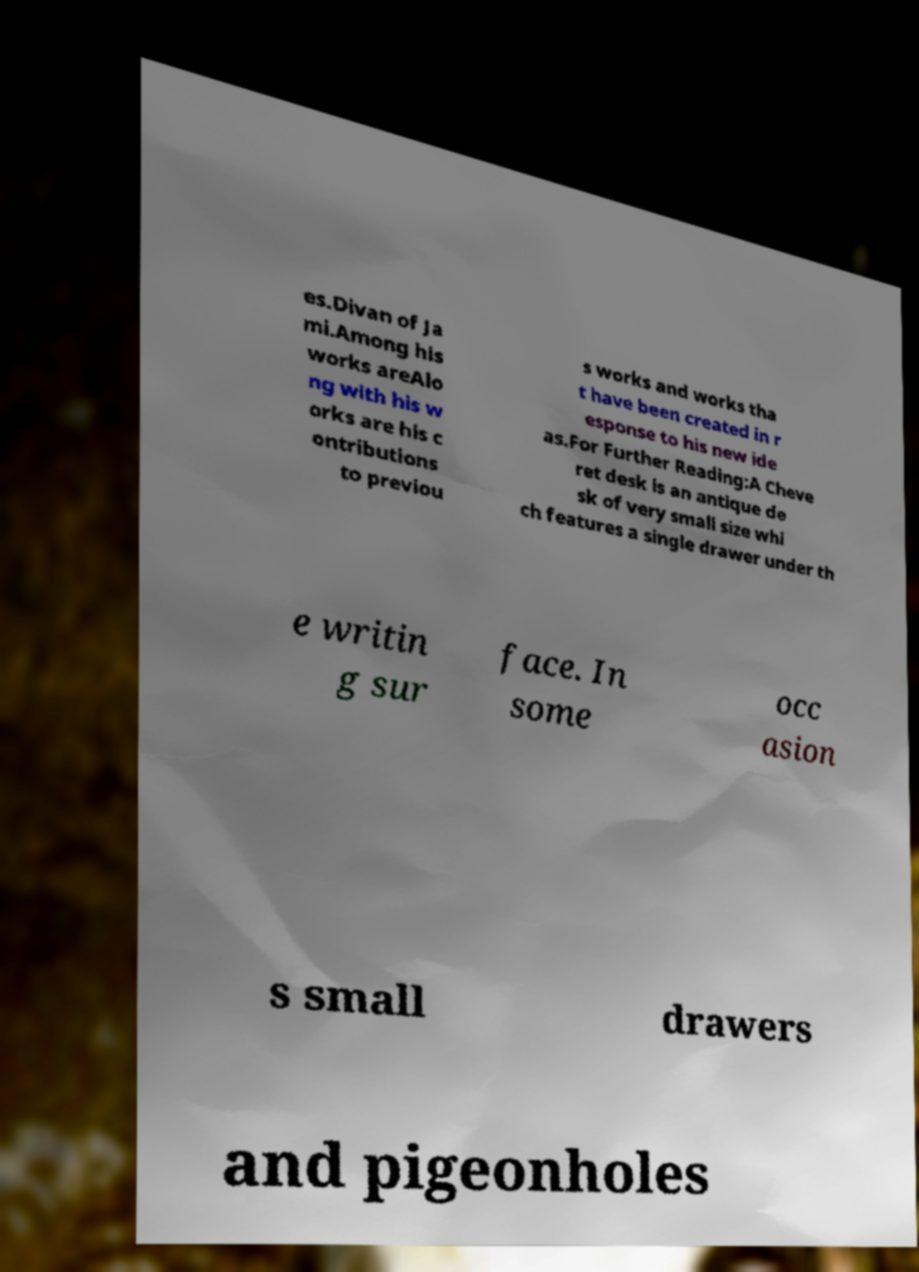Could you extract and type out the text from this image? es.Divan of Ja mi.Among his works areAlo ng with his w orks are his c ontributions to previou s works and works tha t have been created in r esponse to his new ide as.For Further Reading:A Cheve ret desk is an antique de sk of very small size whi ch features a single drawer under th e writin g sur face. In some occ asion s small drawers and pigeonholes 